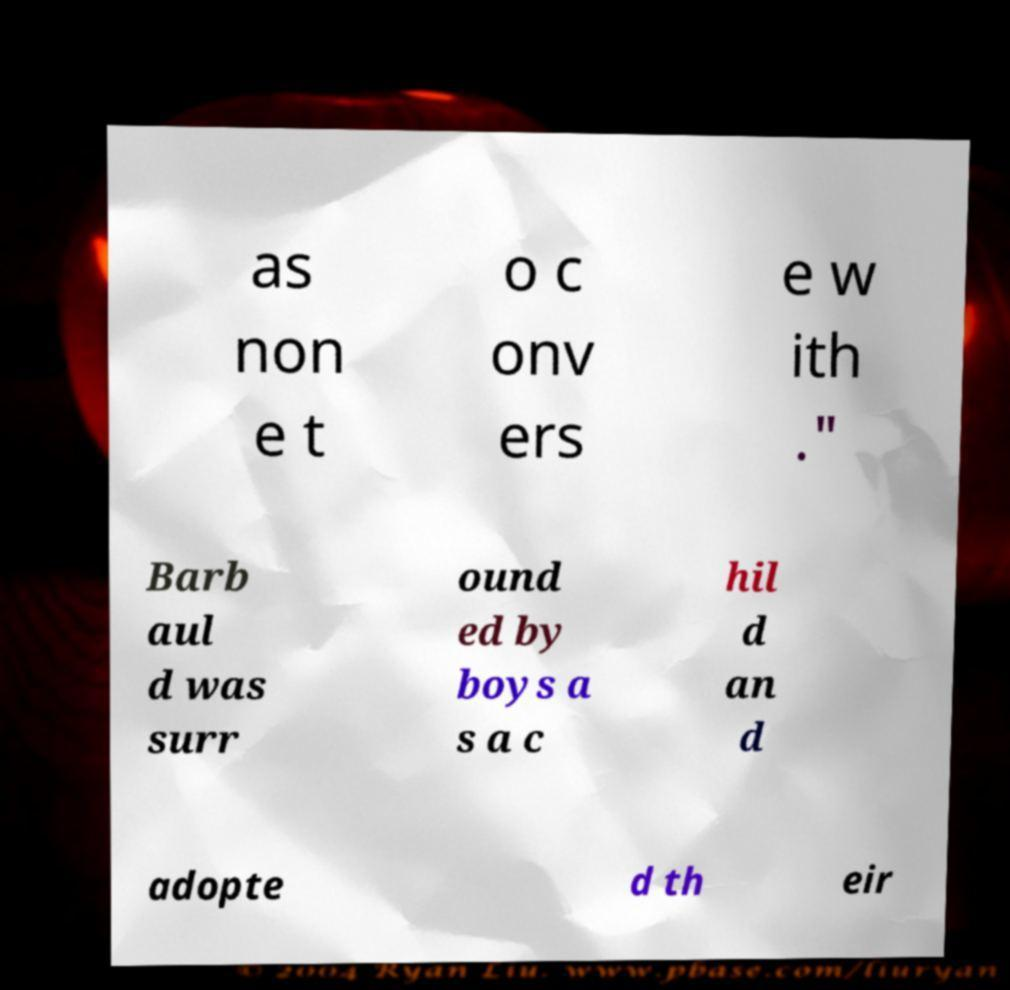Could you assist in decoding the text presented in this image and type it out clearly? as non e t o c onv ers e w ith ." Barb aul d was surr ound ed by boys a s a c hil d an d adopte d th eir 